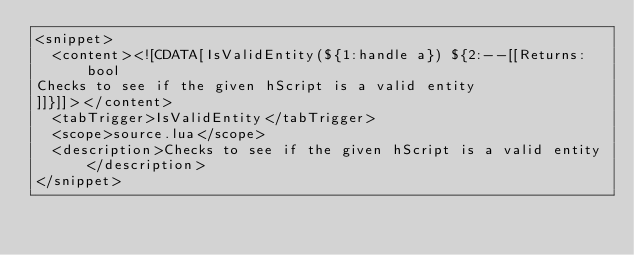<code> <loc_0><loc_0><loc_500><loc_500><_XML_><snippet>
	<content><![CDATA[IsValidEntity(${1:handle a}) ${2:--[[Returns:bool
Checks to see if the given hScript is a valid entity
]]}]]></content>
	<tabTrigger>IsValidEntity</tabTrigger>
	<scope>source.lua</scope>
	<description>Checks to see if the given hScript is a valid entity</description>
</snippet>
</code> 